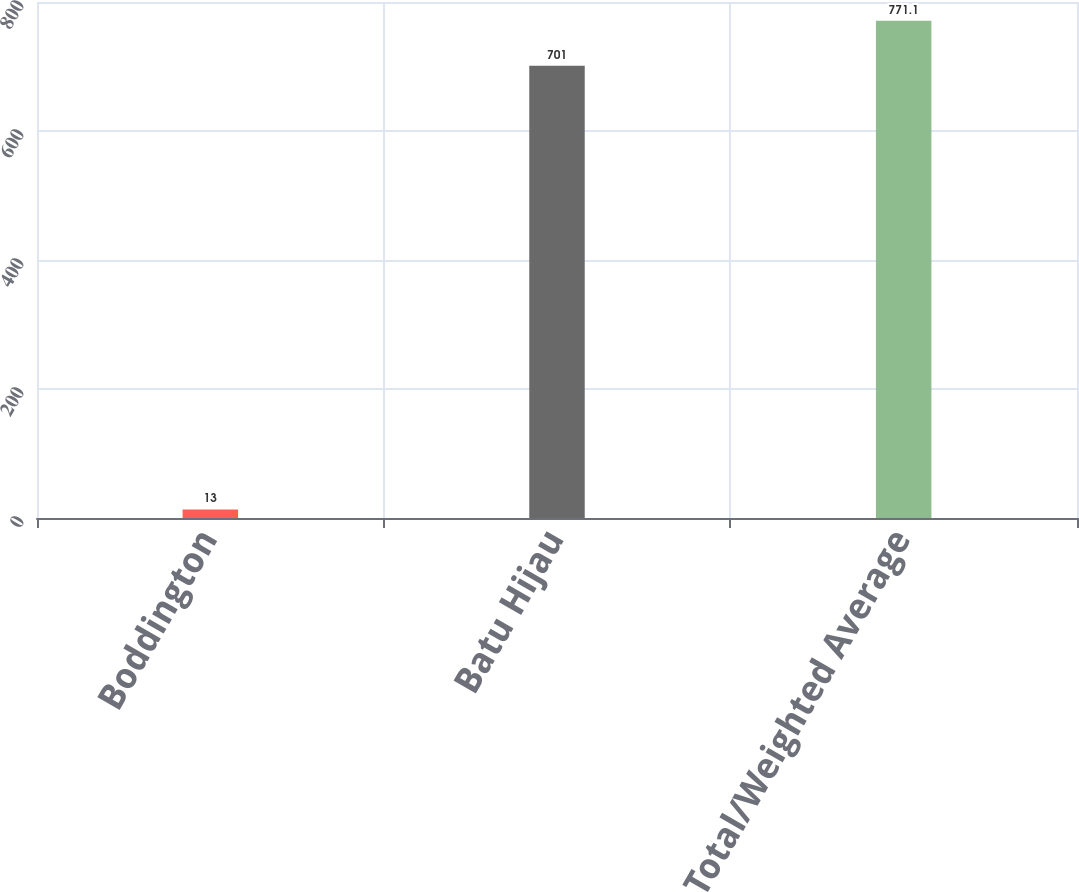Convert chart. <chart><loc_0><loc_0><loc_500><loc_500><bar_chart><fcel>Boddington<fcel>Batu Hijau<fcel>Total/Weighted Average<nl><fcel>13<fcel>701<fcel>771.1<nl></chart> 